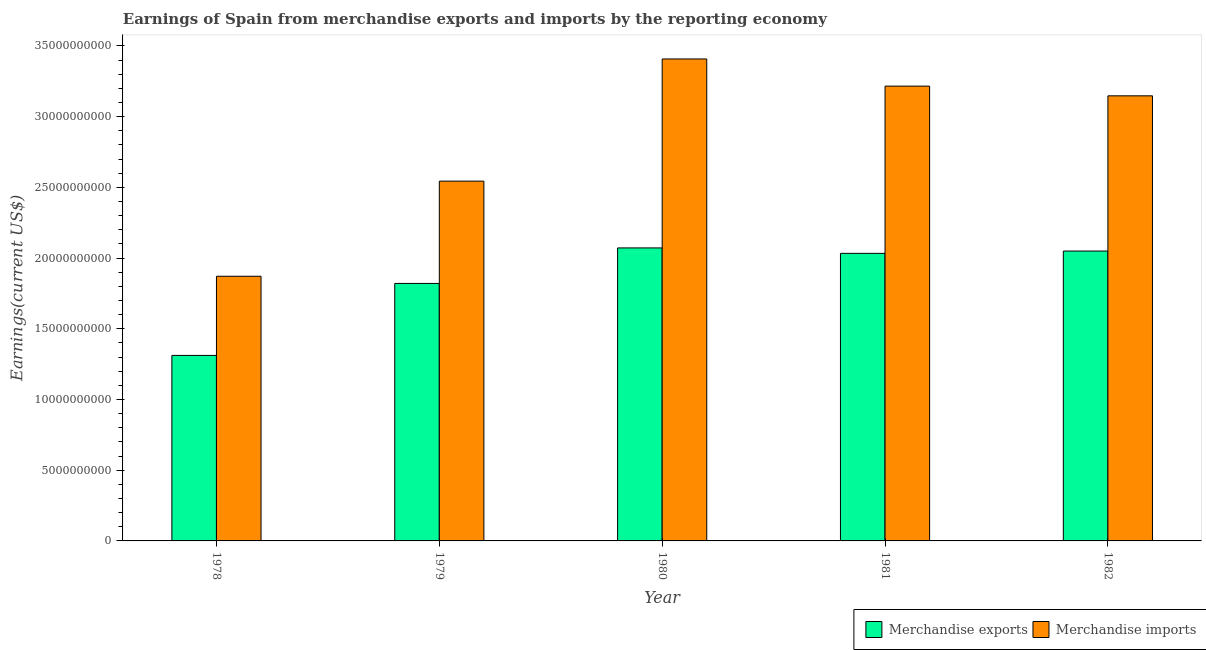How many different coloured bars are there?
Provide a succinct answer. 2. How many groups of bars are there?
Provide a short and direct response. 5. Are the number of bars per tick equal to the number of legend labels?
Provide a succinct answer. Yes. How many bars are there on the 1st tick from the right?
Your response must be concise. 2. What is the label of the 2nd group of bars from the left?
Your response must be concise. 1979. What is the earnings from merchandise imports in 1978?
Your answer should be very brief. 1.87e+1. Across all years, what is the maximum earnings from merchandise exports?
Your response must be concise. 2.07e+1. Across all years, what is the minimum earnings from merchandise imports?
Give a very brief answer. 1.87e+1. In which year was the earnings from merchandise exports minimum?
Your response must be concise. 1978. What is the total earnings from merchandise exports in the graph?
Offer a very short reply. 9.29e+1. What is the difference between the earnings from merchandise exports in 1979 and that in 1981?
Give a very brief answer. -2.13e+09. What is the difference between the earnings from merchandise imports in 1982 and the earnings from merchandise exports in 1980?
Your answer should be very brief. -2.61e+09. What is the average earnings from merchandise exports per year?
Offer a very short reply. 1.86e+1. In the year 1979, what is the difference between the earnings from merchandise imports and earnings from merchandise exports?
Offer a terse response. 0. What is the ratio of the earnings from merchandise exports in 1980 to that in 1981?
Make the answer very short. 1.02. What is the difference between the highest and the second highest earnings from merchandise exports?
Offer a terse response. 2.21e+08. What is the difference between the highest and the lowest earnings from merchandise imports?
Offer a very short reply. 1.54e+1. In how many years, is the earnings from merchandise exports greater than the average earnings from merchandise exports taken over all years?
Your answer should be compact. 3. What does the 1st bar from the left in 1981 represents?
Offer a terse response. Merchandise exports. What does the 2nd bar from the right in 1981 represents?
Your answer should be very brief. Merchandise exports. How many bars are there?
Ensure brevity in your answer.  10. Are the values on the major ticks of Y-axis written in scientific E-notation?
Your answer should be very brief. No. Does the graph contain any zero values?
Provide a short and direct response. No. Where does the legend appear in the graph?
Your answer should be very brief. Bottom right. How are the legend labels stacked?
Give a very brief answer. Horizontal. What is the title of the graph?
Make the answer very short. Earnings of Spain from merchandise exports and imports by the reporting economy. What is the label or title of the Y-axis?
Provide a short and direct response. Earnings(current US$). What is the Earnings(current US$) in Merchandise exports in 1978?
Your answer should be compact. 1.31e+1. What is the Earnings(current US$) in Merchandise imports in 1978?
Keep it short and to the point. 1.87e+1. What is the Earnings(current US$) of Merchandise exports in 1979?
Your response must be concise. 1.82e+1. What is the Earnings(current US$) of Merchandise imports in 1979?
Your answer should be very brief. 2.54e+1. What is the Earnings(current US$) of Merchandise exports in 1980?
Provide a succinct answer. 2.07e+1. What is the Earnings(current US$) of Merchandise imports in 1980?
Provide a short and direct response. 3.41e+1. What is the Earnings(current US$) of Merchandise exports in 1981?
Your answer should be compact. 2.03e+1. What is the Earnings(current US$) of Merchandise imports in 1981?
Give a very brief answer. 3.22e+1. What is the Earnings(current US$) of Merchandise exports in 1982?
Your response must be concise. 2.05e+1. What is the Earnings(current US$) in Merchandise imports in 1982?
Ensure brevity in your answer.  3.15e+1. Across all years, what is the maximum Earnings(current US$) of Merchandise exports?
Offer a terse response. 2.07e+1. Across all years, what is the maximum Earnings(current US$) in Merchandise imports?
Your answer should be very brief. 3.41e+1. Across all years, what is the minimum Earnings(current US$) of Merchandise exports?
Your answer should be very brief. 1.31e+1. Across all years, what is the minimum Earnings(current US$) in Merchandise imports?
Provide a short and direct response. 1.87e+1. What is the total Earnings(current US$) of Merchandise exports in the graph?
Provide a short and direct response. 9.29e+1. What is the total Earnings(current US$) in Merchandise imports in the graph?
Your response must be concise. 1.42e+11. What is the difference between the Earnings(current US$) in Merchandise exports in 1978 and that in 1979?
Offer a terse response. -5.09e+09. What is the difference between the Earnings(current US$) in Merchandise imports in 1978 and that in 1979?
Provide a short and direct response. -6.72e+09. What is the difference between the Earnings(current US$) in Merchandise exports in 1978 and that in 1980?
Your response must be concise. -7.60e+09. What is the difference between the Earnings(current US$) in Merchandise imports in 1978 and that in 1980?
Provide a succinct answer. -1.54e+1. What is the difference between the Earnings(current US$) of Merchandise exports in 1978 and that in 1981?
Offer a terse response. -7.22e+09. What is the difference between the Earnings(current US$) in Merchandise imports in 1978 and that in 1981?
Provide a short and direct response. -1.34e+1. What is the difference between the Earnings(current US$) in Merchandise exports in 1978 and that in 1982?
Keep it short and to the point. -7.38e+09. What is the difference between the Earnings(current US$) in Merchandise imports in 1978 and that in 1982?
Your answer should be very brief. -1.28e+1. What is the difference between the Earnings(current US$) in Merchandise exports in 1979 and that in 1980?
Offer a terse response. -2.51e+09. What is the difference between the Earnings(current US$) in Merchandise imports in 1979 and that in 1980?
Keep it short and to the point. -8.64e+09. What is the difference between the Earnings(current US$) of Merchandise exports in 1979 and that in 1981?
Your answer should be compact. -2.13e+09. What is the difference between the Earnings(current US$) of Merchandise imports in 1979 and that in 1981?
Provide a succinct answer. -6.72e+09. What is the difference between the Earnings(current US$) of Merchandise exports in 1979 and that in 1982?
Make the answer very short. -2.29e+09. What is the difference between the Earnings(current US$) of Merchandise imports in 1979 and that in 1982?
Provide a short and direct response. -6.03e+09. What is the difference between the Earnings(current US$) of Merchandise exports in 1980 and that in 1981?
Ensure brevity in your answer.  3.84e+08. What is the difference between the Earnings(current US$) of Merchandise imports in 1980 and that in 1981?
Provide a short and direct response. 1.92e+09. What is the difference between the Earnings(current US$) of Merchandise exports in 1980 and that in 1982?
Provide a short and direct response. 2.21e+08. What is the difference between the Earnings(current US$) of Merchandise imports in 1980 and that in 1982?
Ensure brevity in your answer.  2.61e+09. What is the difference between the Earnings(current US$) of Merchandise exports in 1981 and that in 1982?
Provide a short and direct response. -1.63e+08. What is the difference between the Earnings(current US$) of Merchandise imports in 1981 and that in 1982?
Your answer should be very brief. 6.86e+08. What is the difference between the Earnings(current US$) of Merchandise exports in 1978 and the Earnings(current US$) of Merchandise imports in 1979?
Give a very brief answer. -1.23e+1. What is the difference between the Earnings(current US$) of Merchandise exports in 1978 and the Earnings(current US$) of Merchandise imports in 1980?
Provide a short and direct response. -2.10e+1. What is the difference between the Earnings(current US$) of Merchandise exports in 1978 and the Earnings(current US$) of Merchandise imports in 1981?
Provide a short and direct response. -1.90e+1. What is the difference between the Earnings(current US$) of Merchandise exports in 1978 and the Earnings(current US$) of Merchandise imports in 1982?
Keep it short and to the point. -1.84e+1. What is the difference between the Earnings(current US$) of Merchandise exports in 1979 and the Earnings(current US$) of Merchandise imports in 1980?
Keep it short and to the point. -1.59e+1. What is the difference between the Earnings(current US$) of Merchandise exports in 1979 and the Earnings(current US$) of Merchandise imports in 1981?
Provide a short and direct response. -1.39e+1. What is the difference between the Earnings(current US$) in Merchandise exports in 1979 and the Earnings(current US$) in Merchandise imports in 1982?
Ensure brevity in your answer.  -1.33e+1. What is the difference between the Earnings(current US$) of Merchandise exports in 1980 and the Earnings(current US$) of Merchandise imports in 1981?
Offer a very short reply. -1.14e+1. What is the difference between the Earnings(current US$) of Merchandise exports in 1980 and the Earnings(current US$) of Merchandise imports in 1982?
Keep it short and to the point. -1.08e+1. What is the difference between the Earnings(current US$) in Merchandise exports in 1981 and the Earnings(current US$) in Merchandise imports in 1982?
Give a very brief answer. -1.11e+1. What is the average Earnings(current US$) in Merchandise exports per year?
Offer a terse response. 1.86e+1. What is the average Earnings(current US$) in Merchandise imports per year?
Offer a very short reply. 2.84e+1. In the year 1978, what is the difference between the Earnings(current US$) of Merchandise exports and Earnings(current US$) of Merchandise imports?
Offer a very short reply. -5.60e+09. In the year 1979, what is the difference between the Earnings(current US$) in Merchandise exports and Earnings(current US$) in Merchandise imports?
Ensure brevity in your answer.  -7.23e+09. In the year 1980, what is the difference between the Earnings(current US$) of Merchandise exports and Earnings(current US$) of Merchandise imports?
Give a very brief answer. -1.34e+1. In the year 1981, what is the difference between the Earnings(current US$) of Merchandise exports and Earnings(current US$) of Merchandise imports?
Provide a succinct answer. -1.18e+1. In the year 1982, what is the difference between the Earnings(current US$) in Merchandise exports and Earnings(current US$) in Merchandise imports?
Keep it short and to the point. -1.10e+1. What is the ratio of the Earnings(current US$) in Merchandise exports in 1978 to that in 1979?
Offer a terse response. 0.72. What is the ratio of the Earnings(current US$) in Merchandise imports in 1978 to that in 1979?
Keep it short and to the point. 0.74. What is the ratio of the Earnings(current US$) in Merchandise exports in 1978 to that in 1980?
Your answer should be very brief. 0.63. What is the ratio of the Earnings(current US$) of Merchandise imports in 1978 to that in 1980?
Provide a succinct answer. 0.55. What is the ratio of the Earnings(current US$) of Merchandise exports in 1978 to that in 1981?
Your answer should be compact. 0.65. What is the ratio of the Earnings(current US$) of Merchandise imports in 1978 to that in 1981?
Offer a terse response. 0.58. What is the ratio of the Earnings(current US$) of Merchandise exports in 1978 to that in 1982?
Provide a short and direct response. 0.64. What is the ratio of the Earnings(current US$) of Merchandise imports in 1978 to that in 1982?
Your answer should be very brief. 0.59. What is the ratio of the Earnings(current US$) of Merchandise exports in 1979 to that in 1980?
Offer a terse response. 0.88. What is the ratio of the Earnings(current US$) of Merchandise imports in 1979 to that in 1980?
Offer a very short reply. 0.75. What is the ratio of the Earnings(current US$) of Merchandise exports in 1979 to that in 1981?
Your answer should be very brief. 0.9. What is the ratio of the Earnings(current US$) in Merchandise imports in 1979 to that in 1981?
Offer a terse response. 0.79. What is the ratio of the Earnings(current US$) of Merchandise exports in 1979 to that in 1982?
Provide a short and direct response. 0.89. What is the ratio of the Earnings(current US$) of Merchandise imports in 1979 to that in 1982?
Offer a terse response. 0.81. What is the ratio of the Earnings(current US$) in Merchandise exports in 1980 to that in 1981?
Your response must be concise. 1.02. What is the ratio of the Earnings(current US$) of Merchandise imports in 1980 to that in 1981?
Provide a succinct answer. 1.06. What is the ratio of the Earnings(current US$) of Merchandise exports in 1980 to that in 1982?
Offer a terse response. 1.01. What is the ratio of the Earnings(current US$) of Merchandise imports in 1980 to that in 1982?
Give a very brief answer. 1.08. What is the ratio of the Earnings(current US$) in Merchandise imports in 1981 to that in 1982?
Provide a short and direct response. 1.02. What is the difference between the highest and the second highest Earnings(current US$) of Merchandise exports?
Your answer should be compact. 2.21e+08. What is the difference between the highest and the second highest Earnings(current US$) in Merchandise imports?
Offer a terse response. 1.92e+09. What is the difference between the highest and the lowest Earnings(current US$) of Merchandise exports?
Offer a very short reply. 7.60e+09. What is the difference between the highest and the lowest Earnings(current US$) of Merchandise imports?
Your response must be concise. 1.54e+1. 